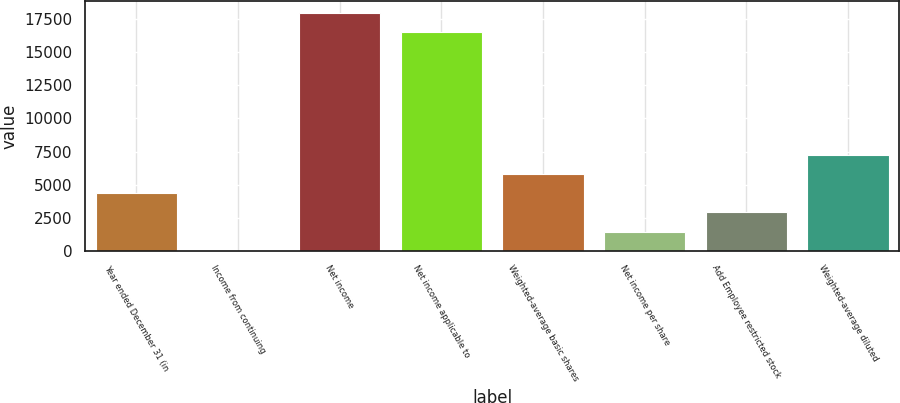Convert chart to OTSL. <chart><loc_0><loc_0><loc_500><loc_500><bar_chart><fcel>Year ended December 31 (in<fcel>Income from continuing<fcel>Net income<fcel>Net income applicable to<fcel>Weighted-average basic shares<fcel>Net income per share<fcel>Add Employee restricted stock<fcel>Weighted-average diluted<nl><fcel>4335.96<fcel>3.93<fcel>17981<fcel>16537<fcel>5779.97<fcel>1447.94<fcel>2891.95<fcel>7223.98<nl></chart> 